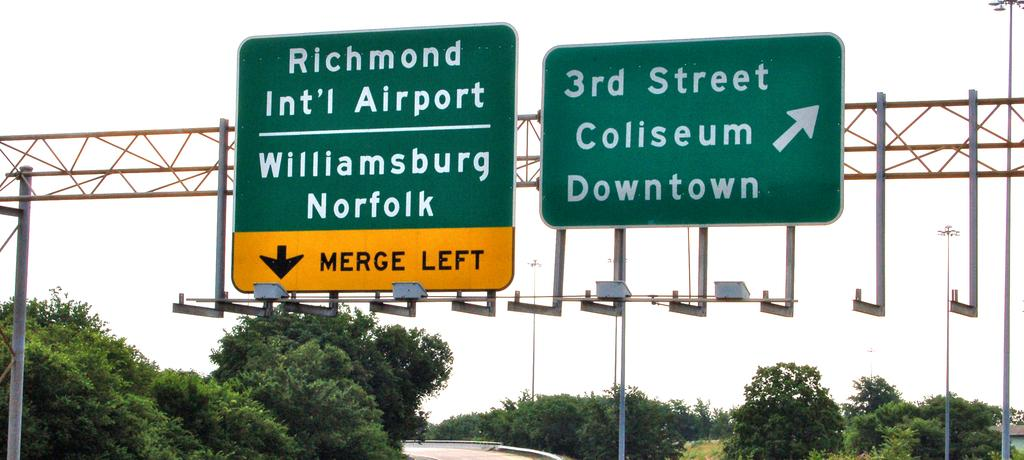<image>
Give a short and clear explanation of the subsequent image. A merge left sign points to the Richmond International Airport. 